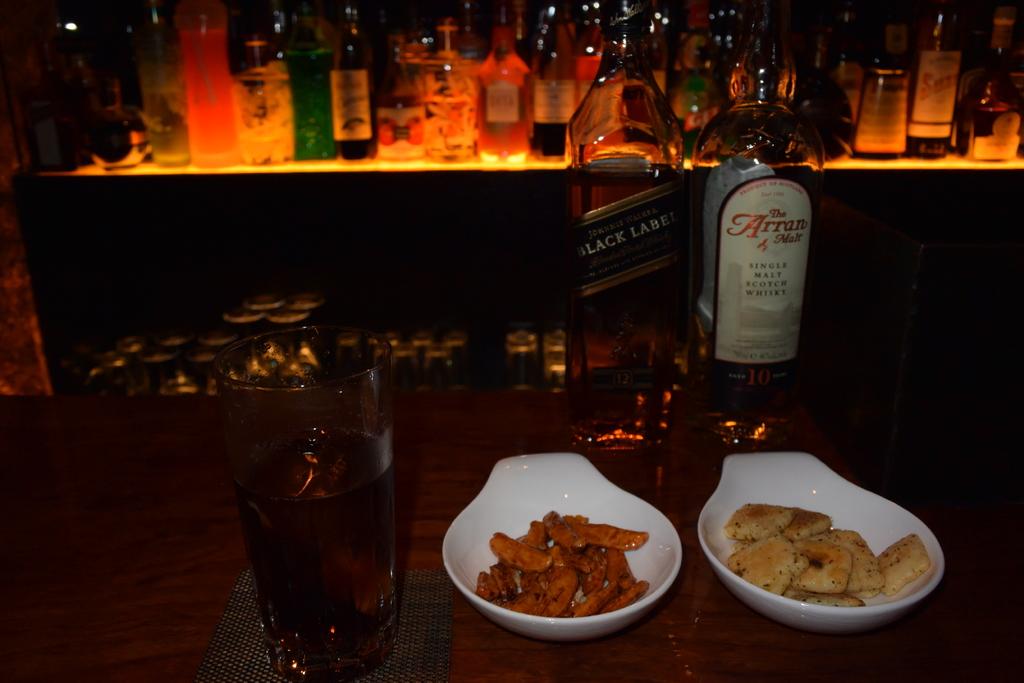What whisky is that?
Your answer should be compact. Black label. Are they drinking black label alcohol?
Your response must be concise. Yes. 